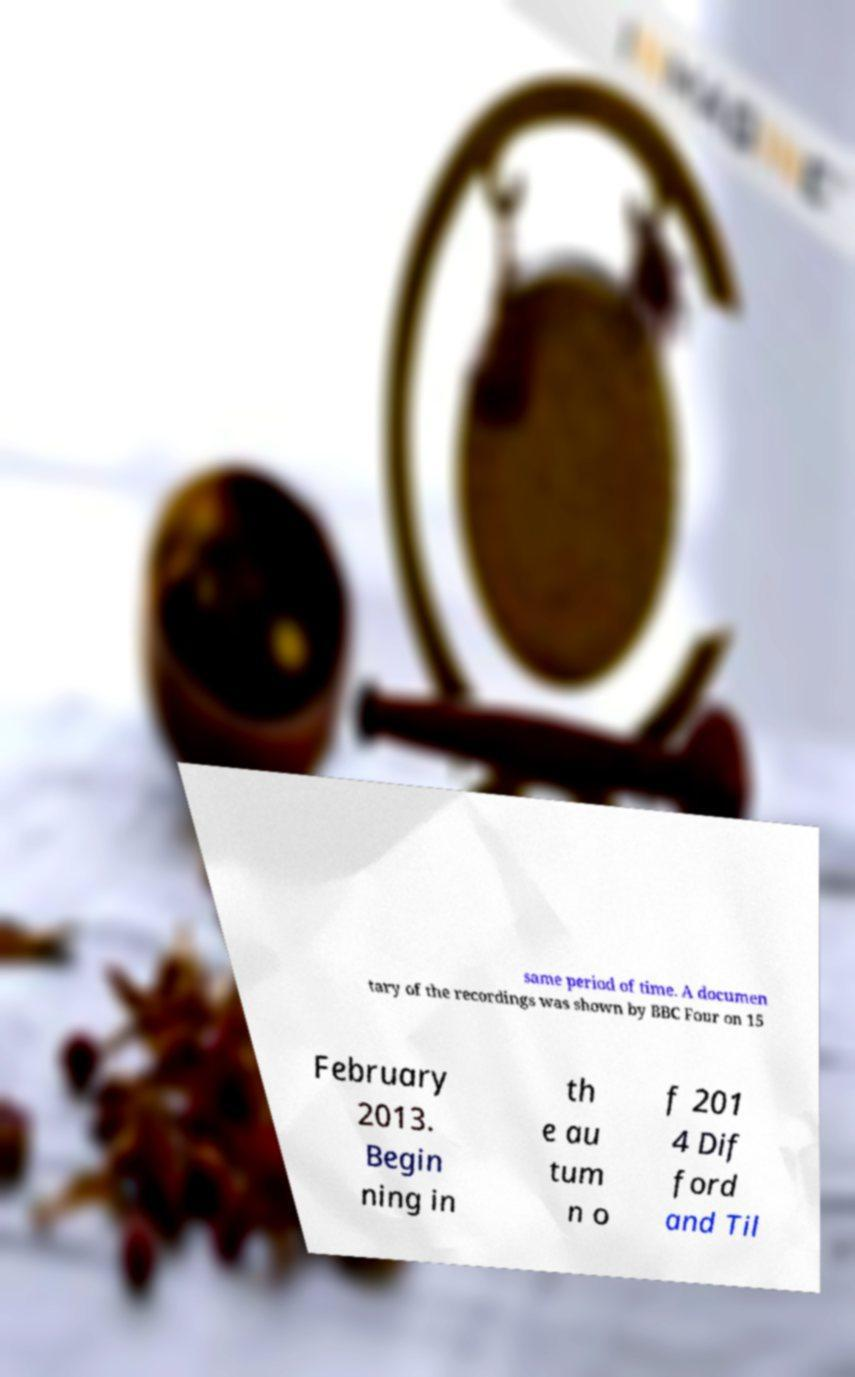What messages or text are displayed in this image? I need them in a readable, typed format. same period of time. A documen tary of the recordings was shown by BBC Four on 15 February 2013. Begin ning in th e au tum n o f 201 4 Dif ford and Til 